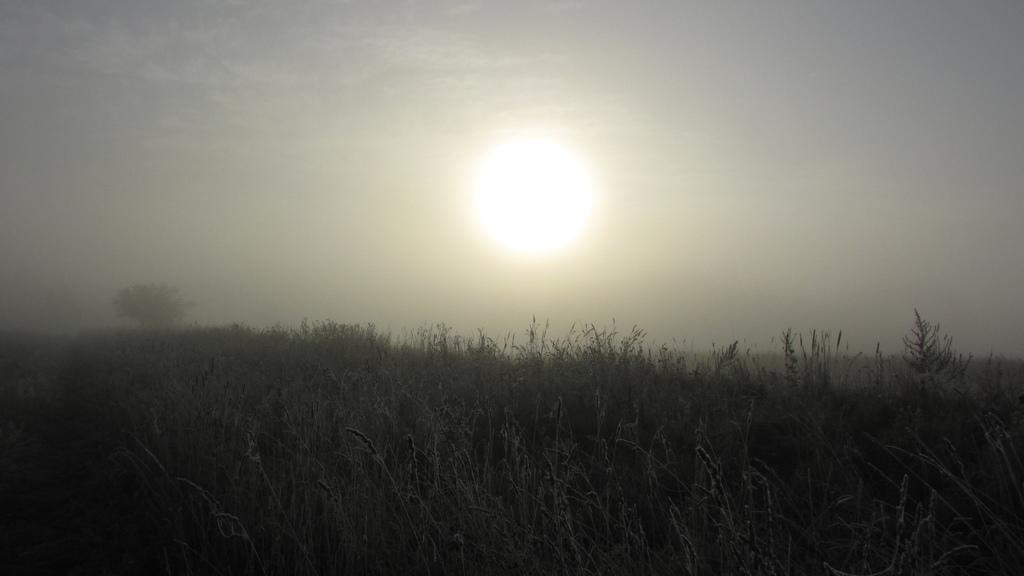Could you give a brief overview of what you see in this image? In this image I can see few plants and a tree. In the background I can see the sky and the sun. 